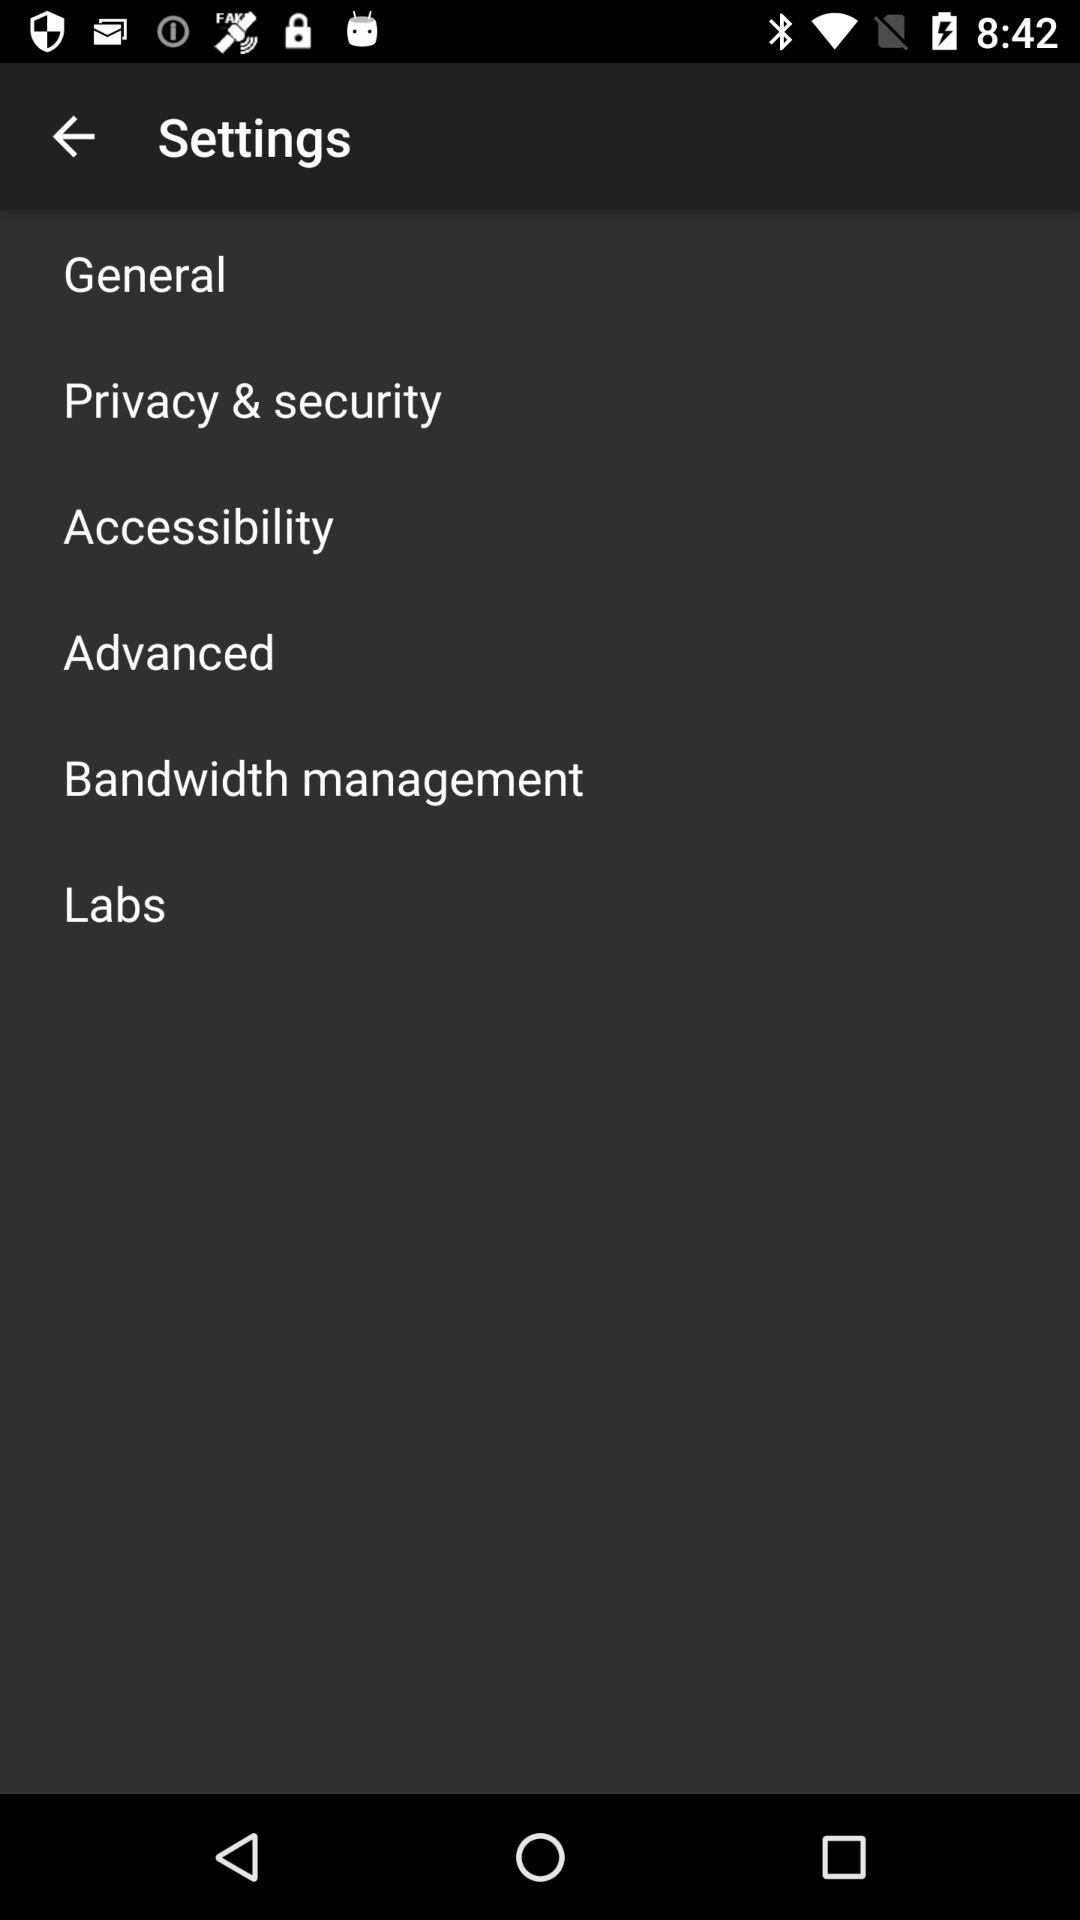How many items are in the Settings menu?
Answer the question using a single word or phrase. 6 